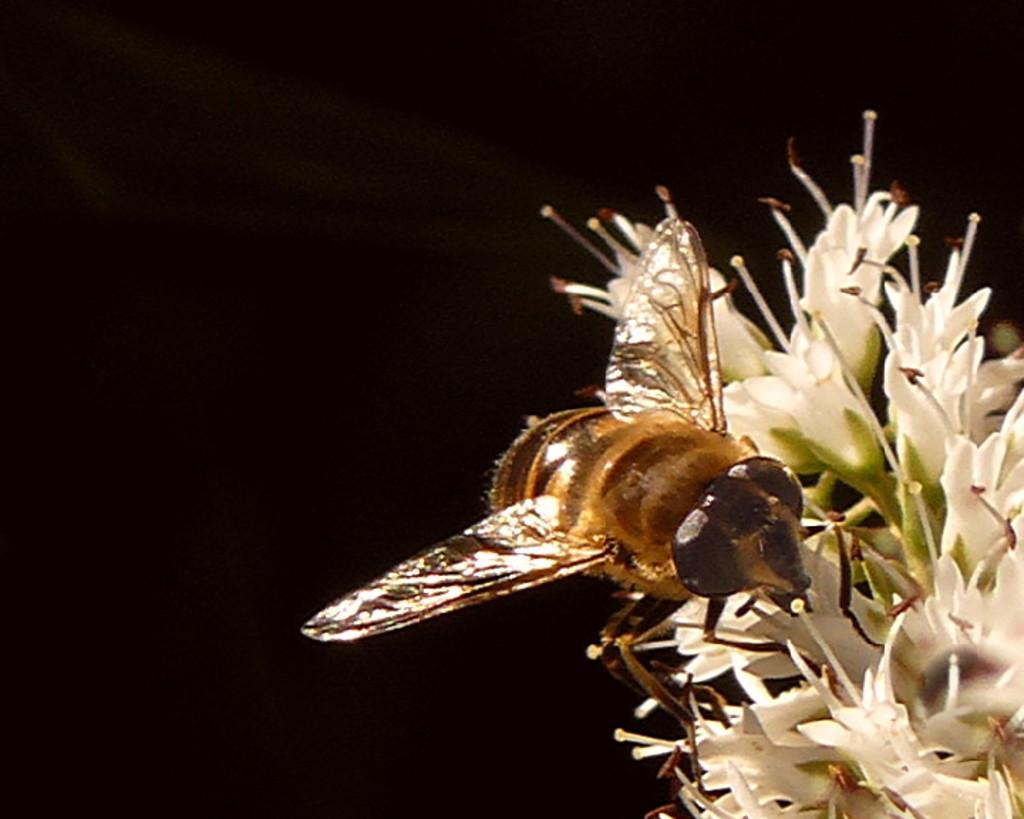Please provide a concise description of this image. In this image we can see one insect on the white flowers on the right side of the of the image and the background is dark. 